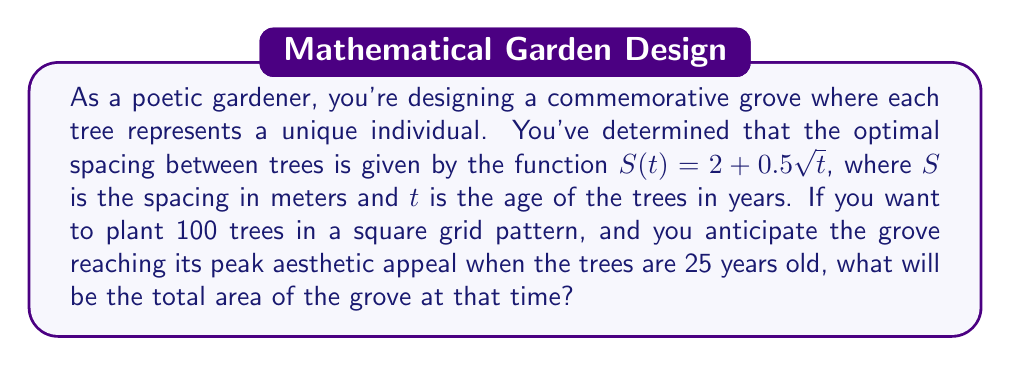Can you answer this question? Let's approach this step-by-step:

1) First, we need to calculate the optimal spacing when the trees are 25 years old:
   $S(25) = 2 + 0.5\sqrt{25} = 2 + 0.5(5) = 2 + 2.5 = 4.5$ meters

2) Now, we know that we want to plant 100 trees in a square grid. This means we'll have 10 trees on each side of the square (since $\sqrt{100} = 10$).

3) To calculate the length of one side of the grove, we need to multiply the number of spaces between trees (which is one less than the number of trees) by the spacing, and then add one more spacing for the outer edge:
   $L = (10-1) \times 4.5 + 4.5 = 9 \times 4.5 + 4.5 = 40.5 + 4.5 = 45$ meters

4) The area of the square grove will be the length squared:
   $A = L^2 = 45^2 = 2,025$ square meters

Therefore, the total area of the grove when the trees are 25 years old will be 2,025 square meters.
Answer: 2,025 m² 